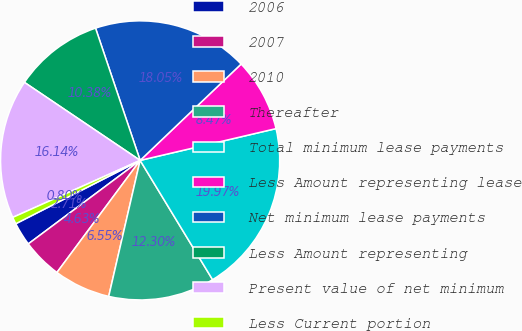Convert chart. <chart><loc_0><loc_0><loc_500><loc_500><pie_chart><fcel>2006<fcel>2007<fcel>2010<fcel>Thereafter<fcel>Total minimum lease payments<fcel>Less Amount representing lease<fcel>Net minimum lease payments<fcel>Less Amount representing<fcel>Present value of net minimum<fcel>Less Current portion<nl><fcel>2.71%<fcel>4.63%<fcel>6.55%<fcel>12.3%<fcel>19.97%<fcel>8.47%<fcel>18.05%<fcel>10.38%<fcel>16.14%<fcel>0.8%<nl></chart> 